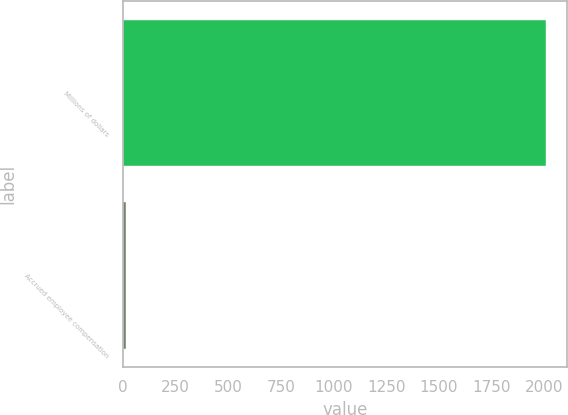Convert chart. <chart><loc_0><loc_0><loc_500><loc_500><bar_chart><fcel>Millions of dollars<fcel>Accrued employee compensation<nl><fcel>2008<fcel>12<nl></chart> 